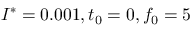<formula> <loc_0><loc_0><loc_500><loc_500>I ^ { * } = 0 . 0 0 1 , t _ { 0 } = 0 , f _ { 0 } = 5</formula> 